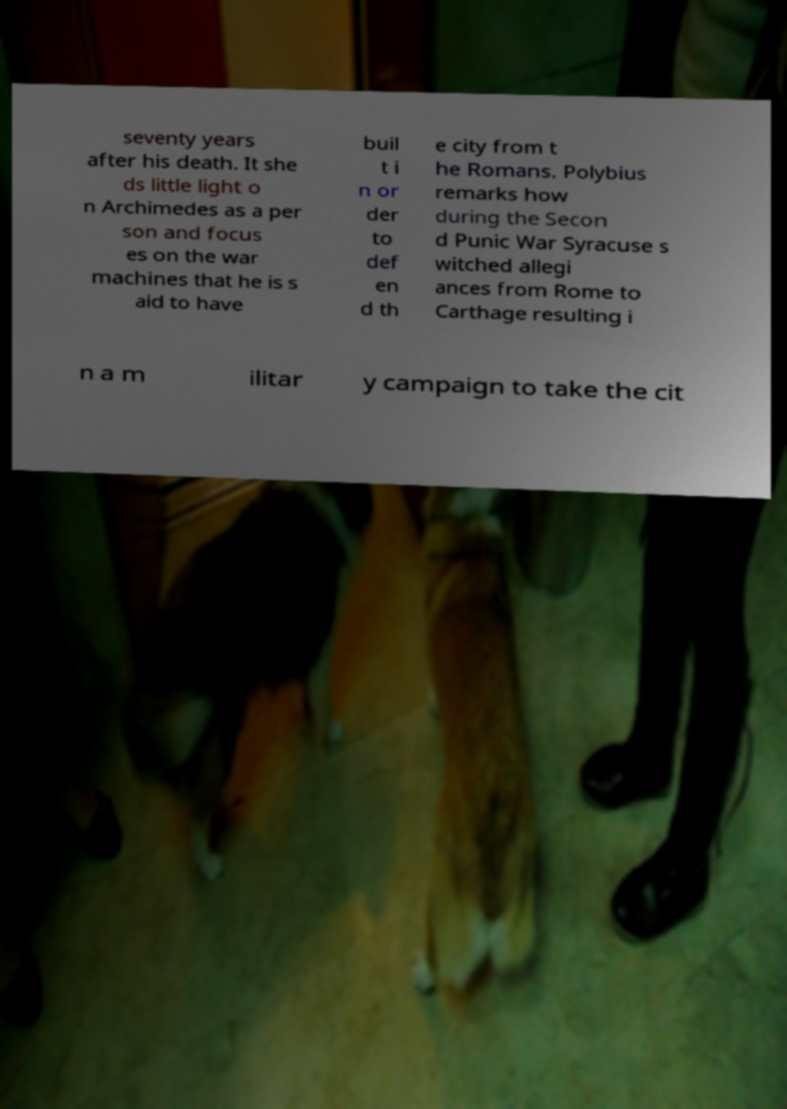What messages or text are displayed in this image? I need them in a readable, typed format. seventy years after his death. It she ds little light o n Archimedes as a per son and focus es on the war machines that he is s aid to have buil t i n or der to def en d th e city from t he Romans. Polybius remarks how during the Secon d Punic War Syracuse s witched allegi ances from Rome to Carthage resulting i n a m ilitar y campaign to take the cit 